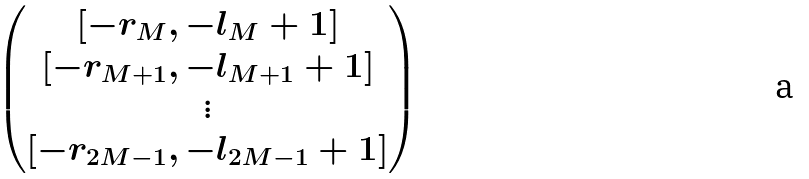<formula> <loc_0><loc_0><loc_500><loc_500>\begin{pmatrix} [ - r _ { M } , - l _ { M } + 1 ] \\ [ - r _ { M + 1 } , - l _ { M + 1 } + 1 ] \\ \vdots \\ [ - r _ { 2 M - 1 } , - l _ { 2 M - 1 } + 1 ] \end{pmatrix}</formula> 